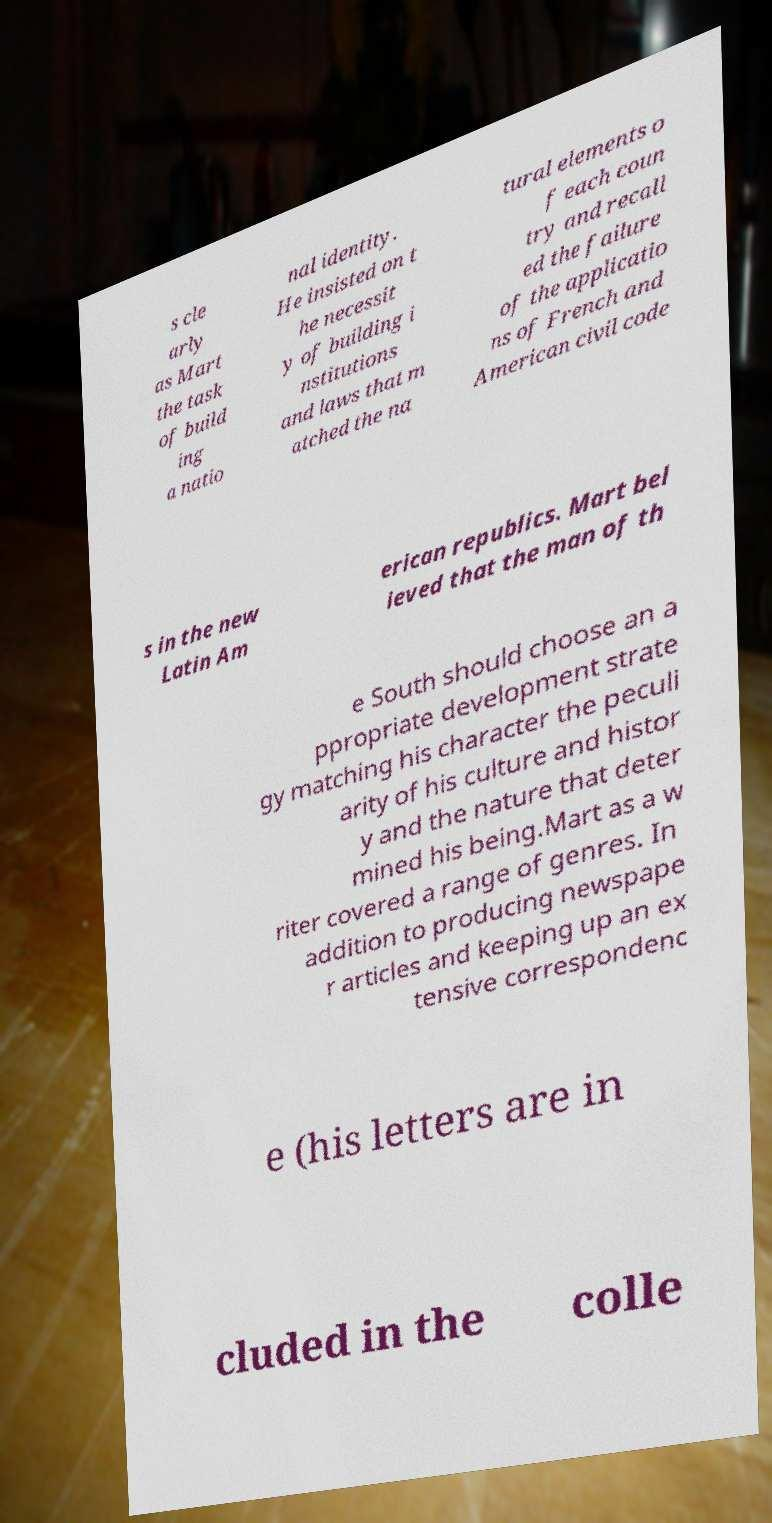I need the written content from this picture converted into text. Can you do that? s cle arly as Mart the task of build ing a natio nal identity. He insisted on t he necessit y of building i nstitutions and laws that m atched the na tural elements o f each coun try and recall ed the failure of the applicatio ns of French and American civil code s in the new Latin Am erican republics. Mart bel ieved that the man of th e South should choose an a ppropriate development strate gy matching his character the peculi arity of his culture and histor y and the nature that deter mined his being.Mart as a w riter covered a range of genres. In addition to producing newspape r articles and keeping up an ex tensive correspondenc e (his letters are in cluded in the colle 